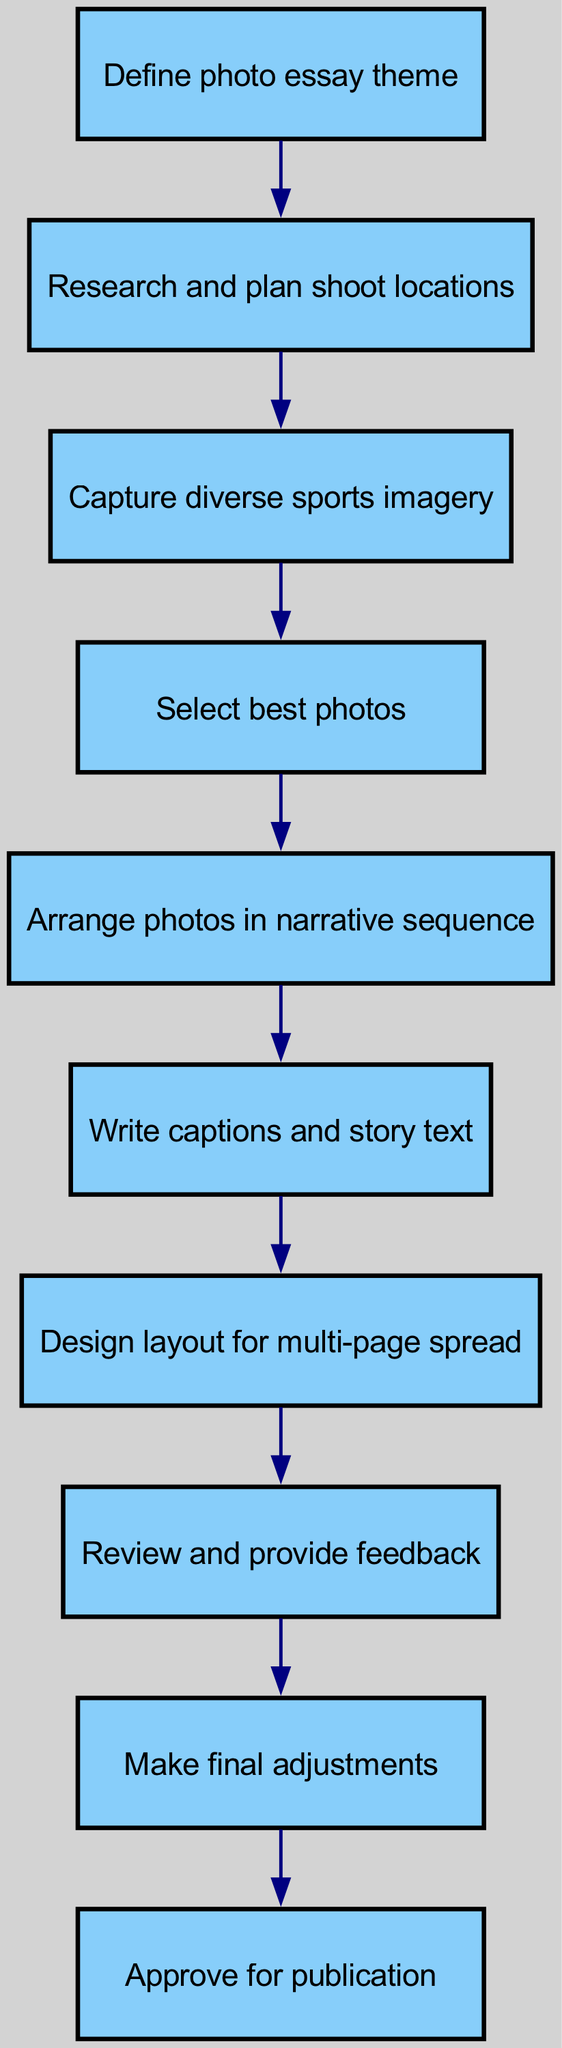What is the first step in the workflow? The first step is represented by the node "Define photo essay theme". It is the starting point of the flow chart and leads to the next step.
Answer: Define photo essay theme How many nodes are in the diagram? The total count of nodes is derived from the individual components listed in the diagram, which amounts to ten distinct nodes representing different steps in the workflow.
Answer: 10 What is the last step before approval for publication? The last step before approval is "Make final adjustments". It is the penultimate action that needs to be completed before the essay is approved for publication.
Answer: Make final adjustments Which step involves planning the shoot locations? The step that involves planning the shoot locations is labeled "Research and plan shoot locations". This action comes immediately after defining the essay theme.
Answer: Research and plan shoot locations How many total edges connect the nodes in the diagram? The number of edges totals nine, as each edge connects two steps in the workflow, accurately represented in the flow chart.
Answer: 9 What two steps follow the selection of the best photos? The two steps following the selection of the best photos are "Arrange photos in narrative sequence" and "Write captions and story text". Both of these elements are crucial for creating a cohesive photo essay.
Answer: Arrange photos in narrative sequence, Write captions and story text What is the primary purpose of the node labeled "Write captions and story text"? The primary purpose of this node is to provide context and narrative to the selected images, thus enhancing the storytelling aspect of the photo essay.
Answer: Provide context and narrative What is the relationship between "Capture diverse sports imagery" and "Select best photos"? The relationship is sequential: "Capture diverse sports imagery" is the step that leads directly to "Select best photos", indicating that good selections are based on the quality of images captured during the shoot.
Answer: Sequential relationship Which step comes after "Review and provide feedback"? The step that comes after "Review and provide feedback" is "Make final adjustments". This indicates a continuous improvement process based on the review conducted.
Answer: Make final adjustments 